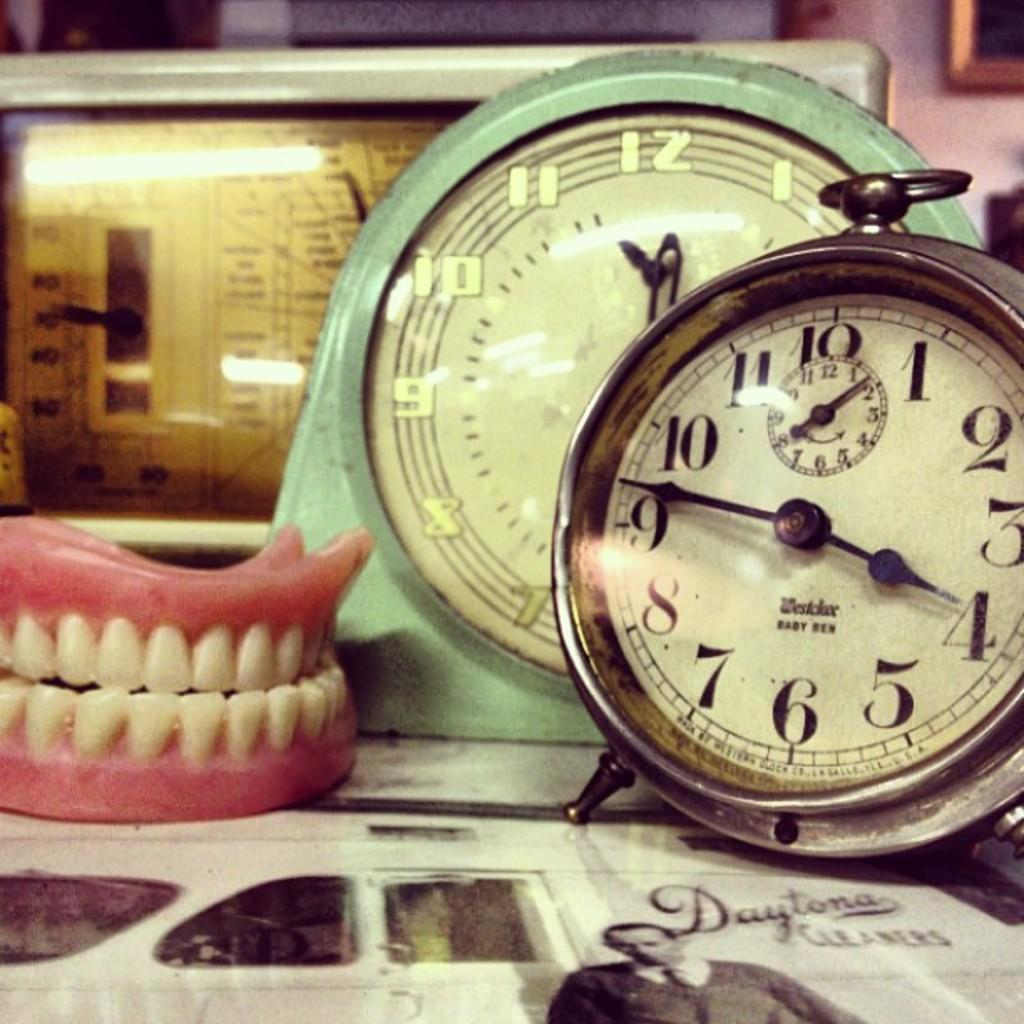<image>
Offer a succinct explanation of the picture presented. Old clocks and false teeth are on a paper with an ad about Daytona cleaners. 